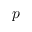<formula> <loc_0><loc_0><loc_500><loc_500>p</formula> 